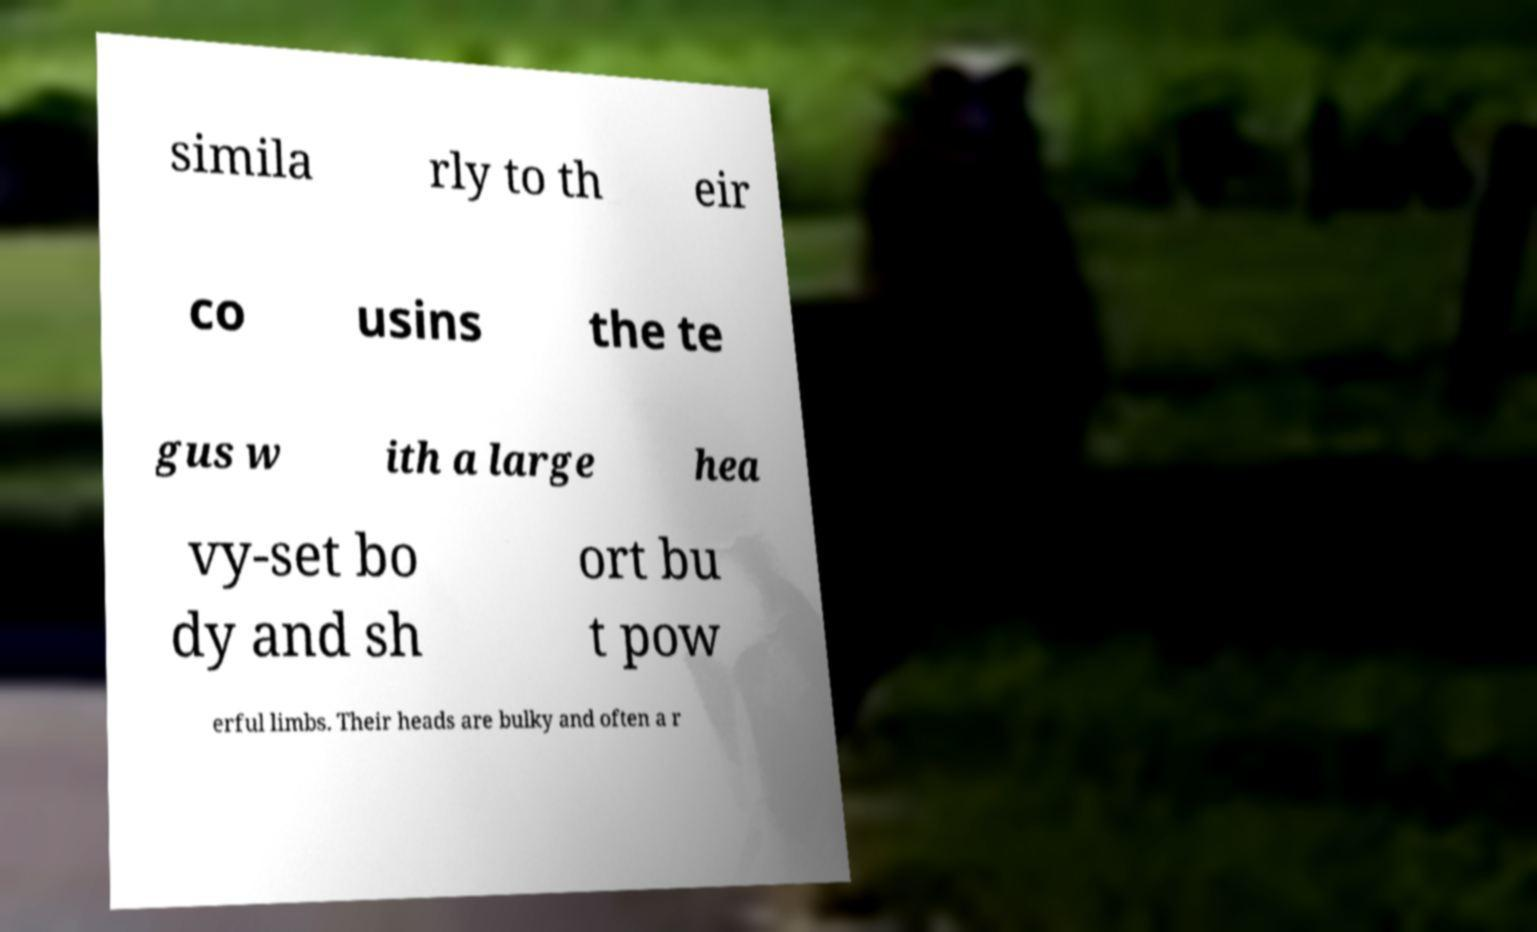There's text embedded in this image that I need extracted. Can you transcribe it verbatim? simila rly to th eir co usins the te gus w ith a large hea vy-set bo dy and sh ort bu t pow erful limbs. Their heads are bulky and often a r 